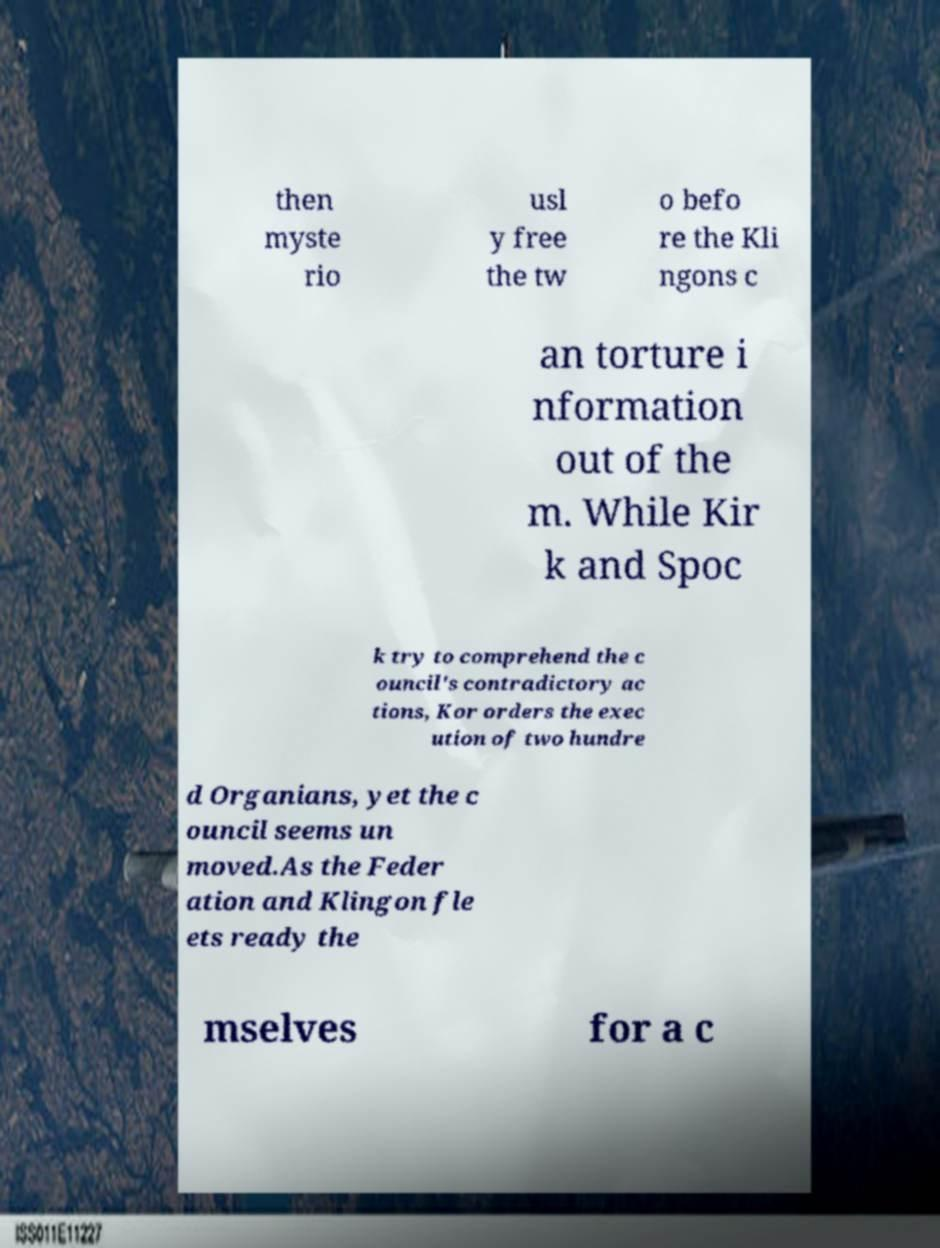Can you accurately transcribe the text from the provided image for me? then myste rio usl y free the tw o befo re the Kli ngons c an torture i nformation out of the m. While Kir k and Spoc k try to comprehend the c ouncil's contradictory ac tions, Kor orders the exec ution of two hundre d Organians, yet the c ouncil seems un moved.As the Feder ation and Klingon fle ets ready the mselves for a c 